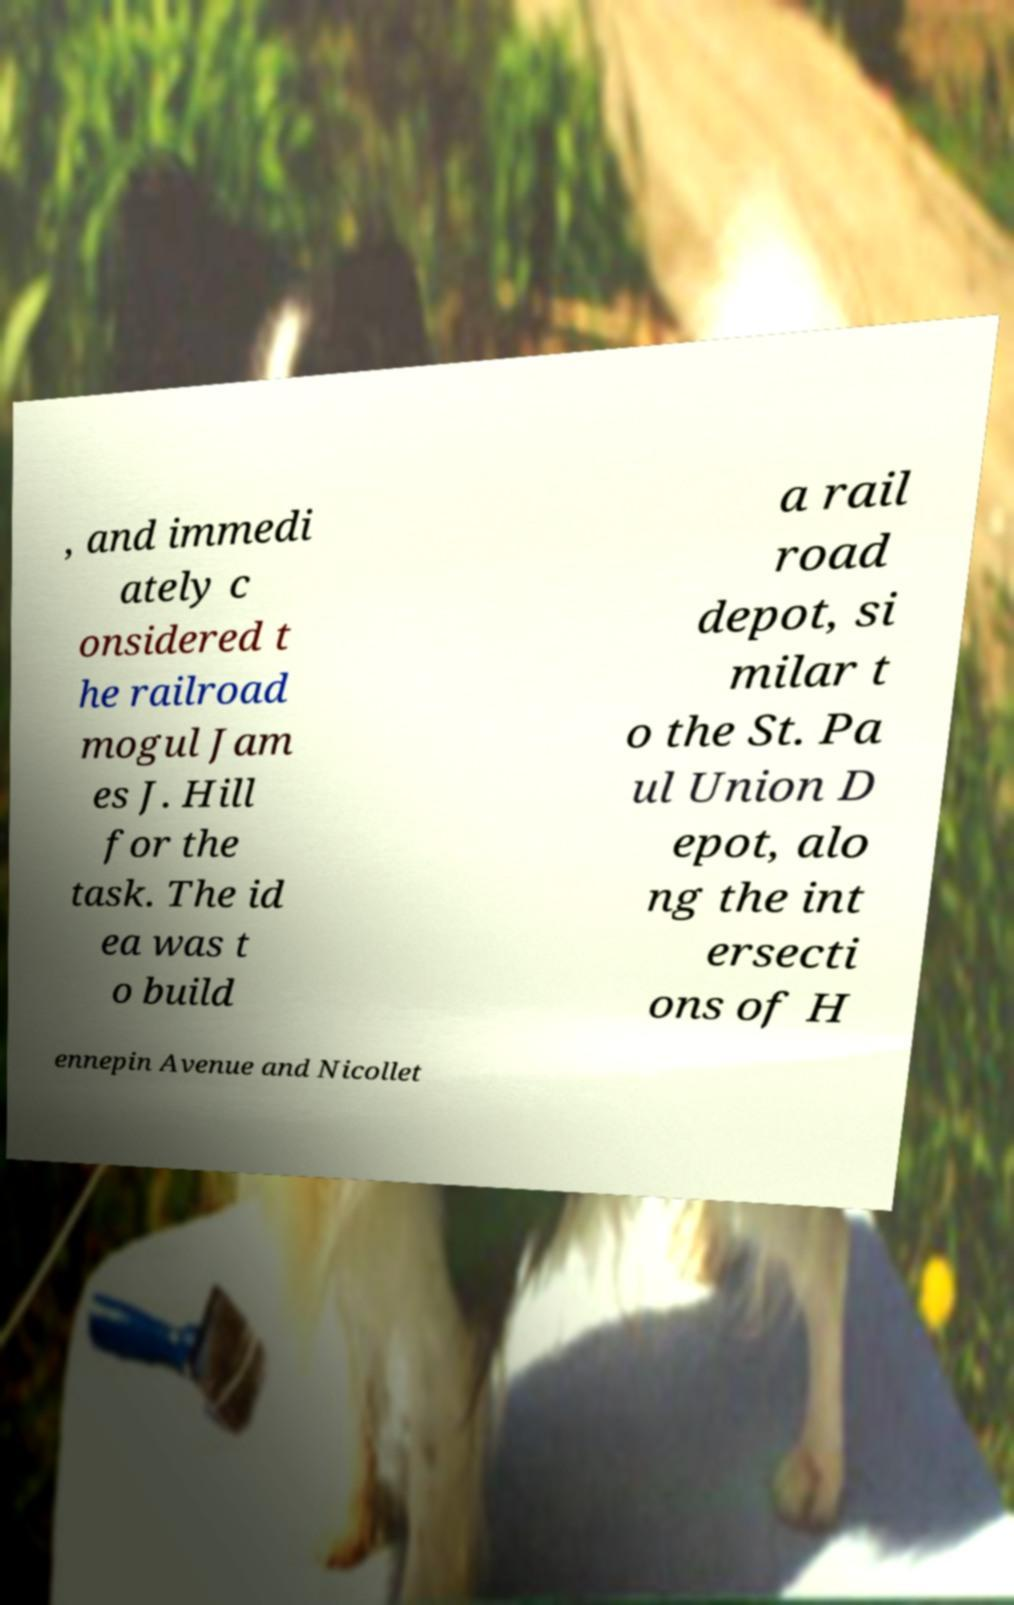Please read and relay the text visible in this image. What does it say? , and immedi ately c onsidered t he railroad mogul Jam es J. Hill for the task. The id ea was t o build a rail road depot, si milar t o the St. Pa ul Union D epot, alo ng the int ersecti ons of H ennepin Avenue and Nicollet 